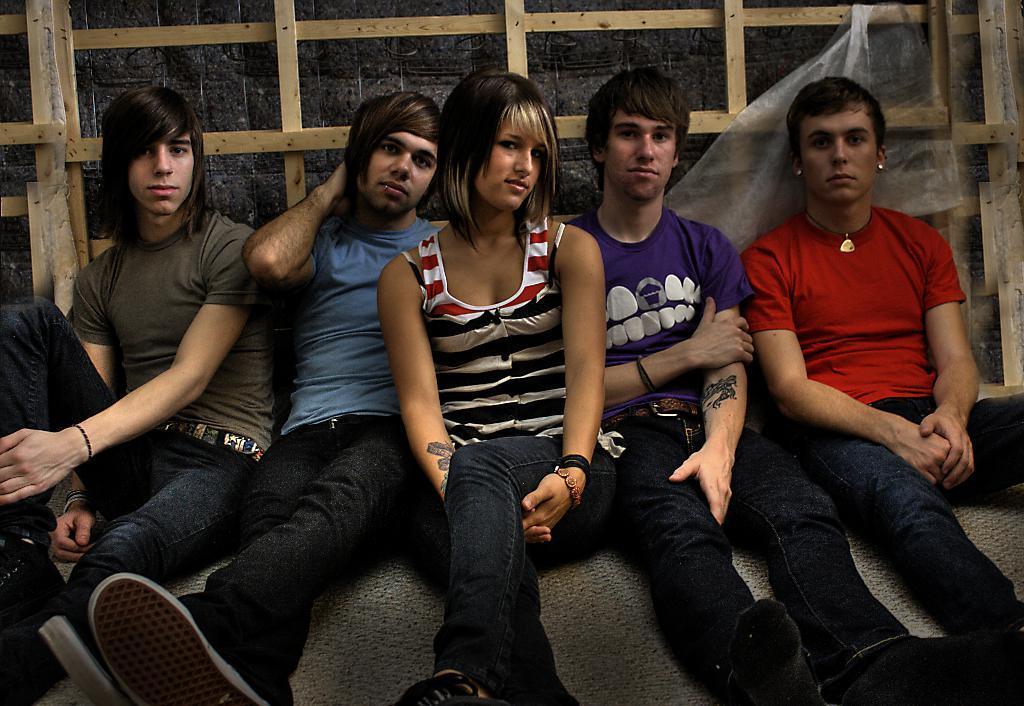Please provide a concise description of this image. In the picture I can see a person wearing grey T-shirt, a person wearing blue T-shirt, a woman wearing white and black T-shirt, a person wearing white color T-shirt and a person wearing red color T-shirt are here. They are all sitting on the surface. In the background, we can see the wooden frame to the wall. 